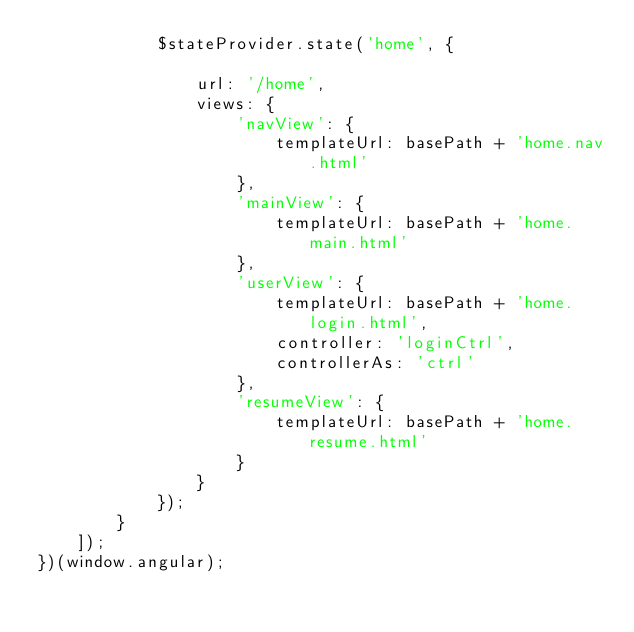Convert code to text. <code><loc_0><loc_0><loc_500><loc_500><_JavaScript_>            $stateProvider.state('home', {

                url: '/home',
                views: {
                    'navView': {
                        templateUrl: basePath + 'home.nav.html'
                    },
                    'mainView': {
                        templateUrl: basePath + 'home.main.html'
                    },
                    'userView': {
                        templateUrl: basePath + 'home.login.html',
                        controller: 'loginCtrl',
                        controllerAs: 'ctrl'
                    },
                    'resumeView': {
                        templateUrl: basePath + 'home.resume.html'
                    }
                }
            });
        }
    ]);
})(window.angular);

</code> 